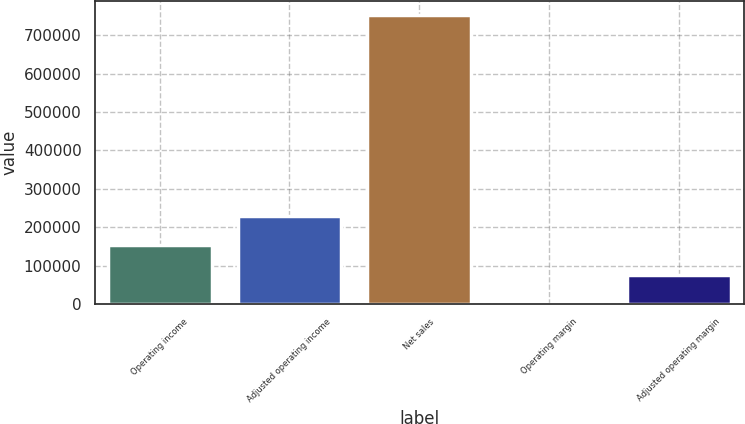Convert chart. <chart><loc_0><loc_0><loc_500><loc_500><bar_chart><fcel>Operating income<fcel>Adjusted operating income<fcel>Net sales<fcel>Operating margin<fcel>Adjusted operating margin<nl><fcel>152999<fcel>228199<fcel>752021<fcel>20.3<fcel>75220.4<nl></chart> 